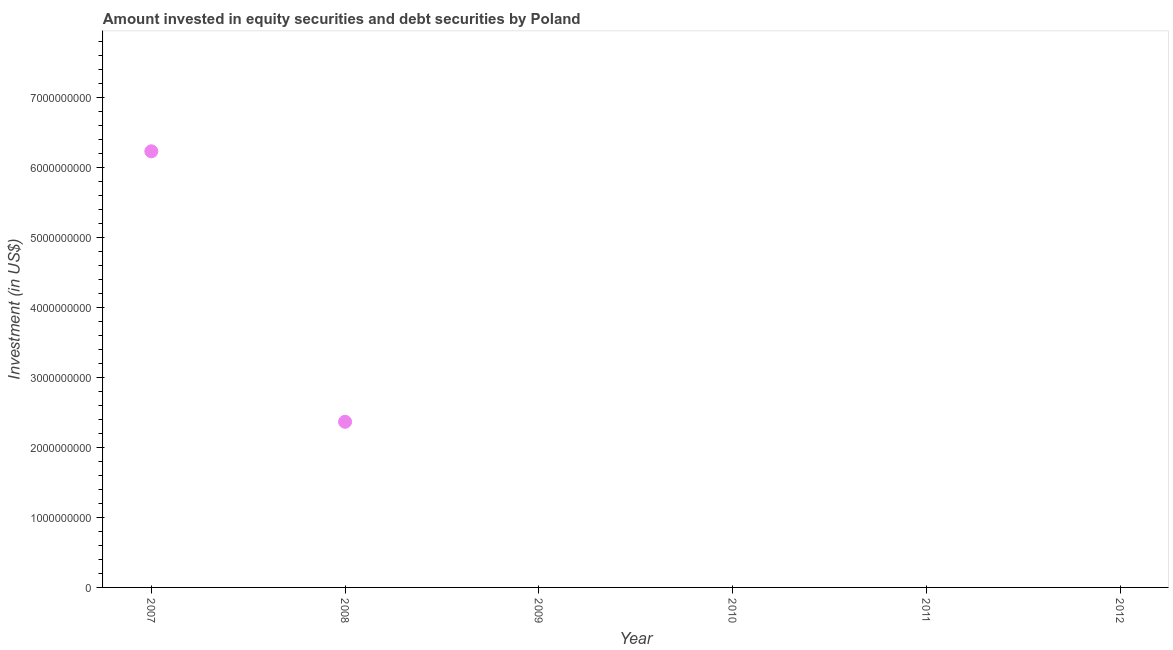What is the portfolio investment in 2007?
Make the answer very short. 6.23e+09. Across all years, what is the maximum portfolio investment?
Your response must be concise. 6.23e+09. Across all years, what is the minimum portfolio investment?
Provide a succinct answer. 0. In which year was the portfolio investment maximum?
Your answer should be compact. 2007. What is the sum of the portfolio investment?
Ensure brevity in your answer.  8.59e+09. What is the average portfolio investment per year?
Keep it short and to the point. 1.43e+09. What is the median portfolio investment?
Provide a succinct answer. 0. In how many years, is the portfolio investment greater than 6000000000 US$?
Offer a very short reply. 1. Is the sum of the portfolio investment in 2007 and 2008 greater than the maximum portfolio investment across all years?
Offer a terse response. Yes. What is the difference between the highest and the lowest portfolio investment?
Offer a terse response. 6.23e+09. In how many years, is the portfolio investment greater than the average portfolio investment taken over all years?
Provide a succinct answer. 2. How many dotlines are there?
Your response must be concise. 1. How many years are there in the graph?
Your answer should be compact. 6. What is the difference between two consecutive major ticks on the Y-axis?
Provide a short and direct response. 1.00e+09. Are the values on the major ticks of Y-axis written in scientific E-notation?
Provide a short and direct response. No. Does the graph contain grids?
Your answer should be very brief. No. What is the title of the graph?
Give a very brief answer. Amount invested in equity securities and debt securities by Poland. What is the label or title of the X-axis?
Ensure brevity in your answer.  Year. What is the label or title of the Y-axis?
Give a very brief answer. Investment (in US$). What is the Investment (in US$) in 2007?
Make the answer very short. 6.23e+09. What is the Investment (in US$) in 2008?
Offer a terse response. 2.36e+09. What is the Investment (in US$) in 2010?
Make the answer very short. 0. What is the Investment (in US$) in 2011?
Provide a short and direct response. 0. What is the Investment (in US$) in 2012?
Offer a very short reply. 0. What is the difference between the Investment (in US$) in 2007 and 2008?
Offer a terse response. 3.86e+09. What is the ratio of the Investment (in US$) in 2007 to that in 2008?
Keep it short and to the point. 2.63. 